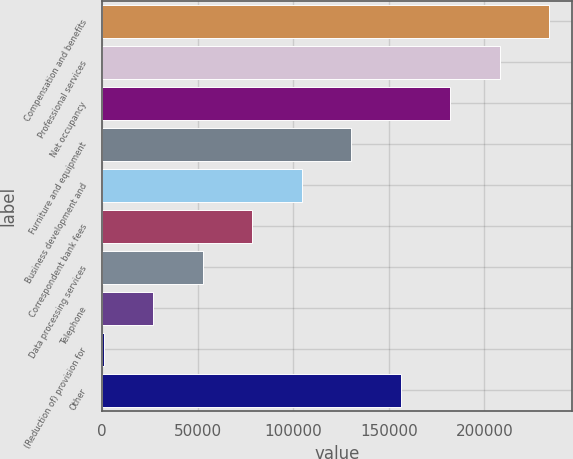Convert chart. <chart><loc_0><loc_0><loc_500><loc_500><bar_chart><fcel>Compensation and benefits<fcel>Professional services<fcel>Net occupancy<fcel>Furniture and equipment<fcel>Business development and<fcel>Correspondent bank fees<fcel>Data processing services<fcel>Telephone<fcel>(Reduction of) provision for<fcel>Other<nl><fcel>233967<fcel>208073<fcel>182180<fcel>130394<fcel>104500<fcel>78606.9<fcel>52713.6<fcel>26820.3<fcel>927<fcel>156287<nl></chart> 